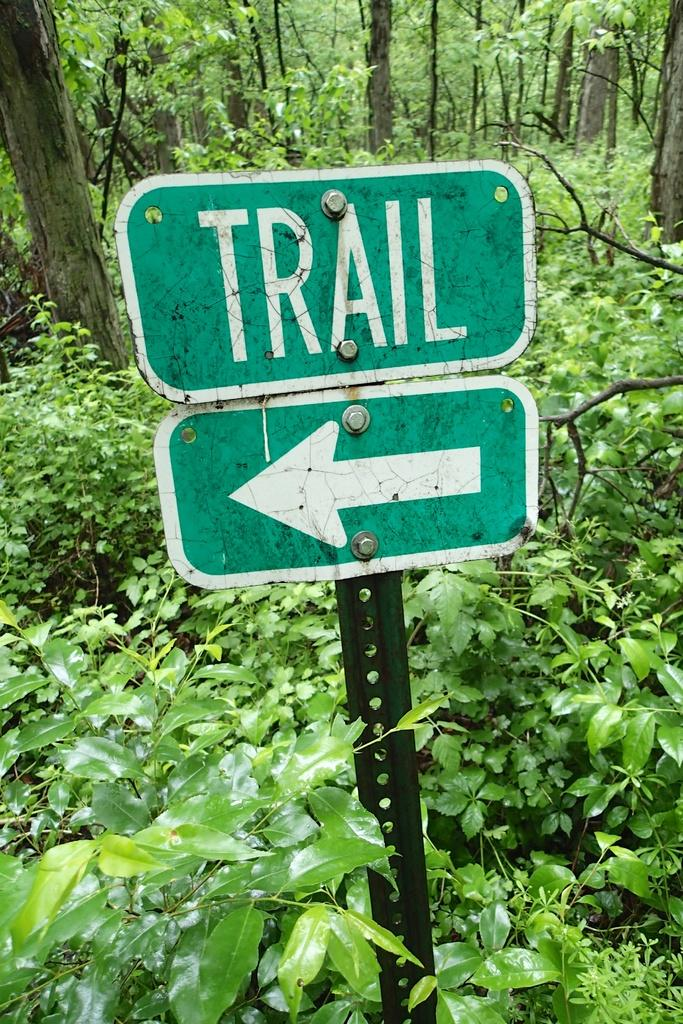<image>
Offer a succinct explanation of the picture presented. A green sign with an arrow says Trail and is in thick woods. 